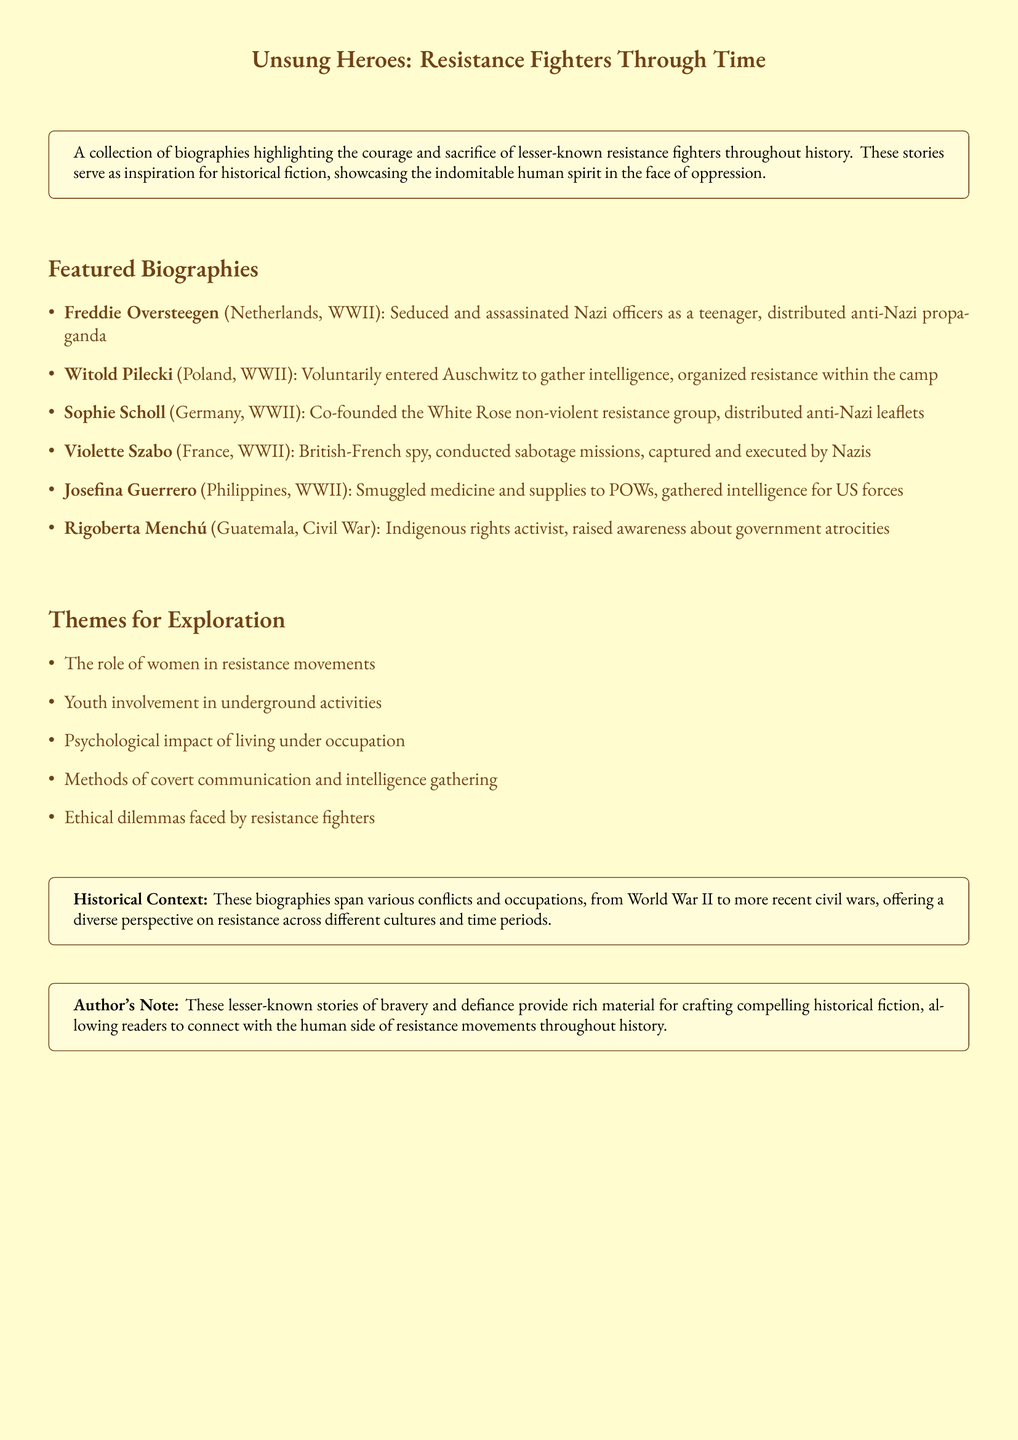What are the names of two resistance fighters featured? The document lists several resistance fighters including Freddie Oversteegen and Witold Pilecki.
Answer: Freddie Oversteegen, Witold Pilecki In which country did Violette Szabo conduct her missions? Violette Szabo is identified as a British-French spy who conducted her sabotage missions in France during WWII.
Answer: France Who co-founded the White Rose group? The document states that Sophie Scholl co-founded the non-violent resistance group known as the White Rose.
Answer: Sophie Scholl What major theme is highlighted regarding resistance movements? The document lists themes for exploration, one of which is the role of women in resistance movements.
Answer: The role of women in resistance movements How many featured biographies are listed in the document? The document details six individual resistance fighters, indicating the number of featured biographies.
Answer: Six What conflict is specifically associated with Josefina Guerrero? The document denotes that Josefina Guerrero was involved in the context of WWII in the Philippines.
Answer: WWII What did Witold Pilecki do at Auschwitz? According to the document, Witold Pilecki voluntarily entered Auschwitz to gather intelligence.
Answer: Gather intelligence What ethical aspect is suggested as a theme for exploration? The document mentions that ethical dilemmas faced by resistance fighters is a potential theme for further exploration.
Answer: Ethical dilemmas faced by resistance fighters 